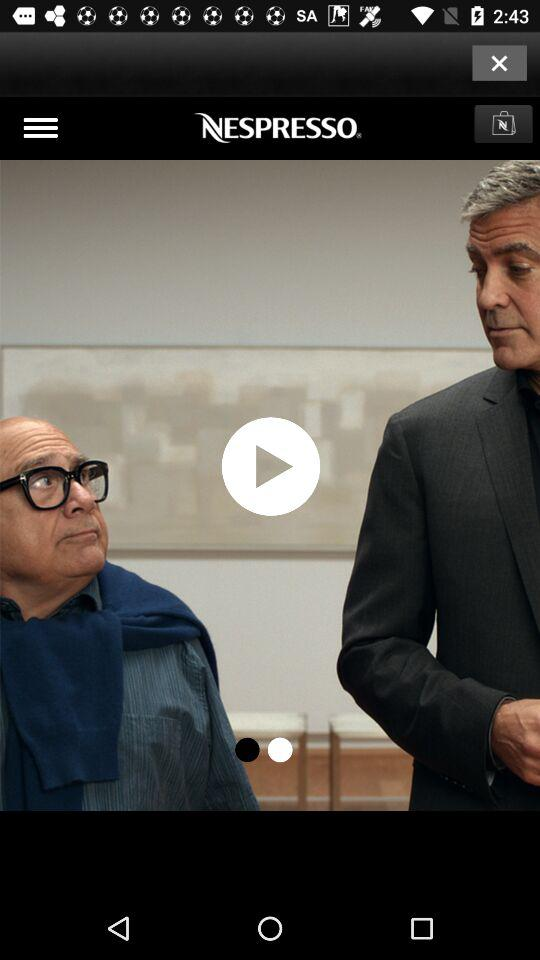What is the name of the application? The name of the application is "NESPRESSO". 